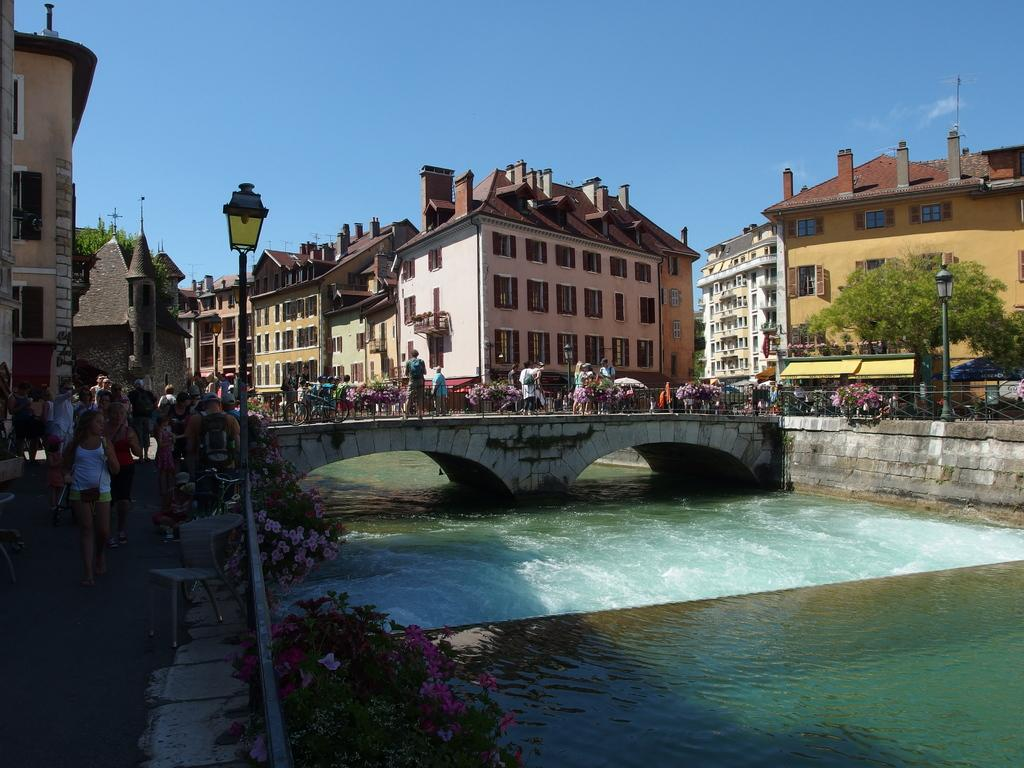What type of location is depicted in the image? The image is of a city. What natural element can be seen in the image? There is water in the image. What man-made structure is present in the image? There is a bridge in the image. What type of vegetation is visible in the image? There are plants with flowers in the image. Can you describe the people in the image? There is a group of people in the image. What type of structures are present in the image? There are buildings in the image. What other type of vegetation is visible in the image? There are trees in the image. What type of poles are present in the image? There are poles in the image. What type of lighting is present in the image? There are lights in the image. What can be seen in the background of the image? The sky is visible in the background of the image. How many beams are being carried by the girls in the image? There are no girls or beams present in the image. What type of things are the girls playing with in the image? There are no girls or things present in the image. 